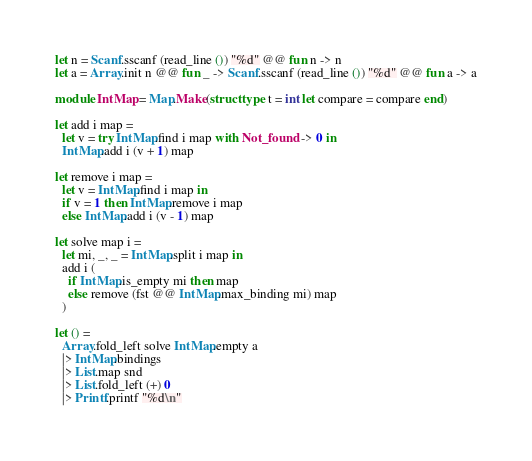Convert code to text. <code><loc_0><loc_0><loc_500><loc_500><_OCaml_>let n = Scanf.sscanf (read_line ()) "%d" @@ fun n -> n
let a = Array.init n @@ fun _ -> Scanf.sscanf (read_line ()) "%d" @@ fun a -> a

module IntMap = Map.Make(struct type t = int let compare = compare end)

let add i map =
  let v = try IntMap.find i map with Not_found -> 0 in
  IntMap.add i (v + 1) map

let remove i map =
  let v = IntMap.find i map in
  if v = 1 then IntMap.remove i map
  else IntMap.add i (v - 1) map

let solve map i =
  let mi, _, _ = IntMap.split i map in
  add i (
    if IntMap.is_empty mi then map
    else remove (fst @@ IntMap.max_binding mi) map
  )

let () = 
  Array.fold_left solve IntMap.empty a
  |> IntMap.bindings
  |> List.map snd
  |> List.fold_left (+) 0
  |> Printf.printf "%d\n"</code> 